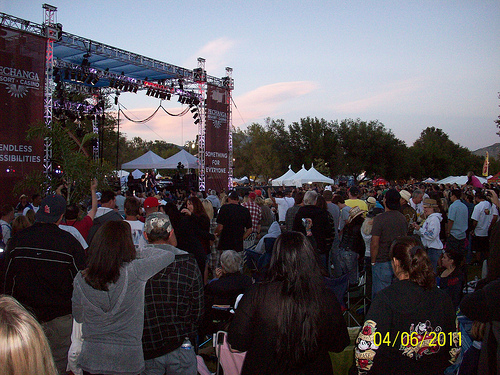<image>
Can you confirm if the sky is behind the tree? Yes. From this viewpoint, the sky is positioned behind the tree, with the tree partially or fully occluding the sky. 